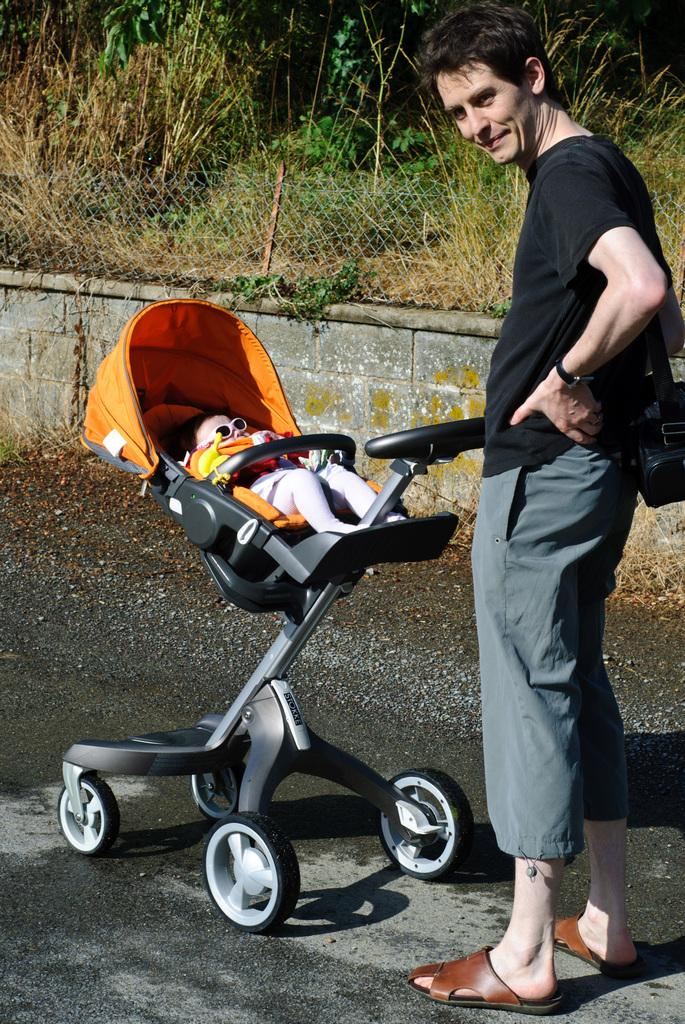What is the main subject of the image? There is a person standing in the image. What else can be seen in the image besides the person? There is a baby in a stroller in the image. What type of vegetation is present on the ground in the image? There are plants and grass on the ground in the image. What type of structure is visible in the background of the image? There is a compound wall visible in the image. What type of brush is being used by the person in the image? There is no brush visible in the image; the person is not holding or using any brush. 